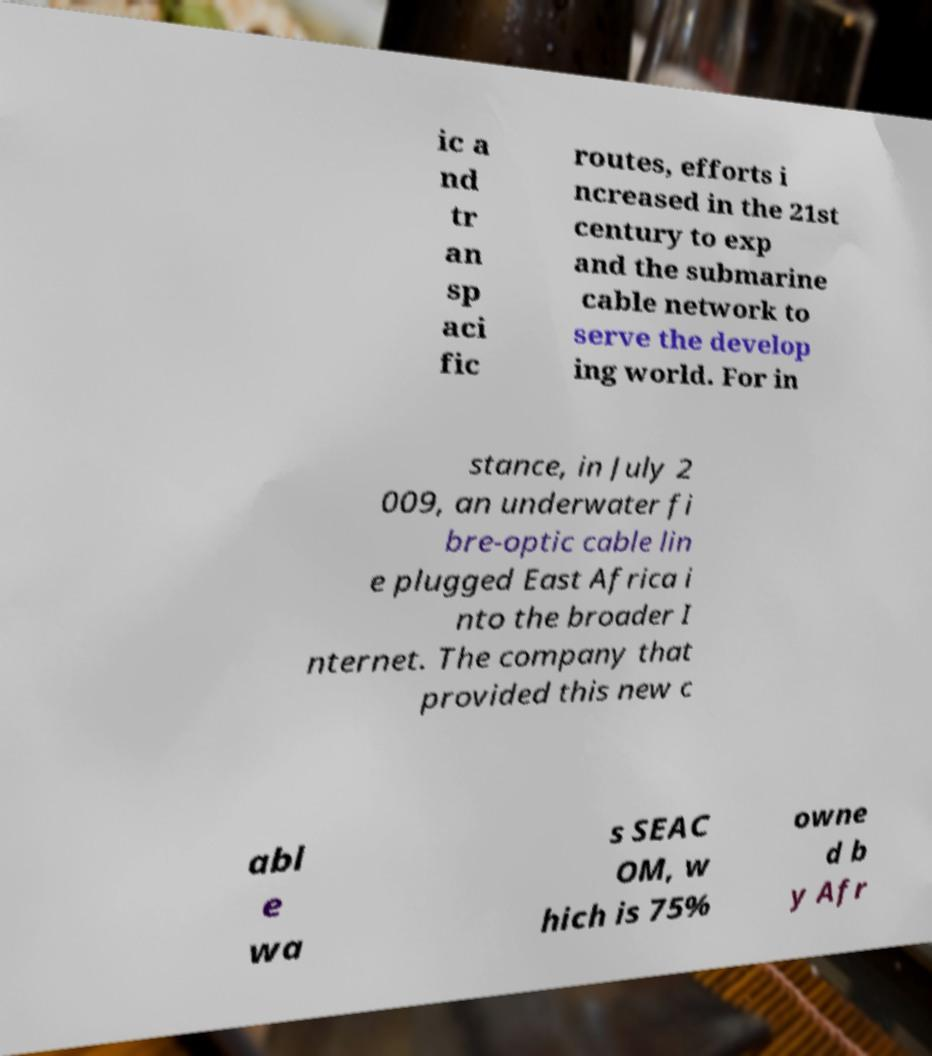Can you read and provide the text displayed in the image?This photo seems to have some interesting text. Can you extract and type it out for me? ic a nd tr an sp aci fic routes, efforts i ncreased in the 21st century to exp and the submarine cable network to serve the develop ing world. For in stance, in July 2 009, an underwater fi bre-optic cable lin e plugged East Africa i nto the broader I nternet. The company that provided this new c abl e wa s SEAC OM, w hich is 75% owne d b y Afr 